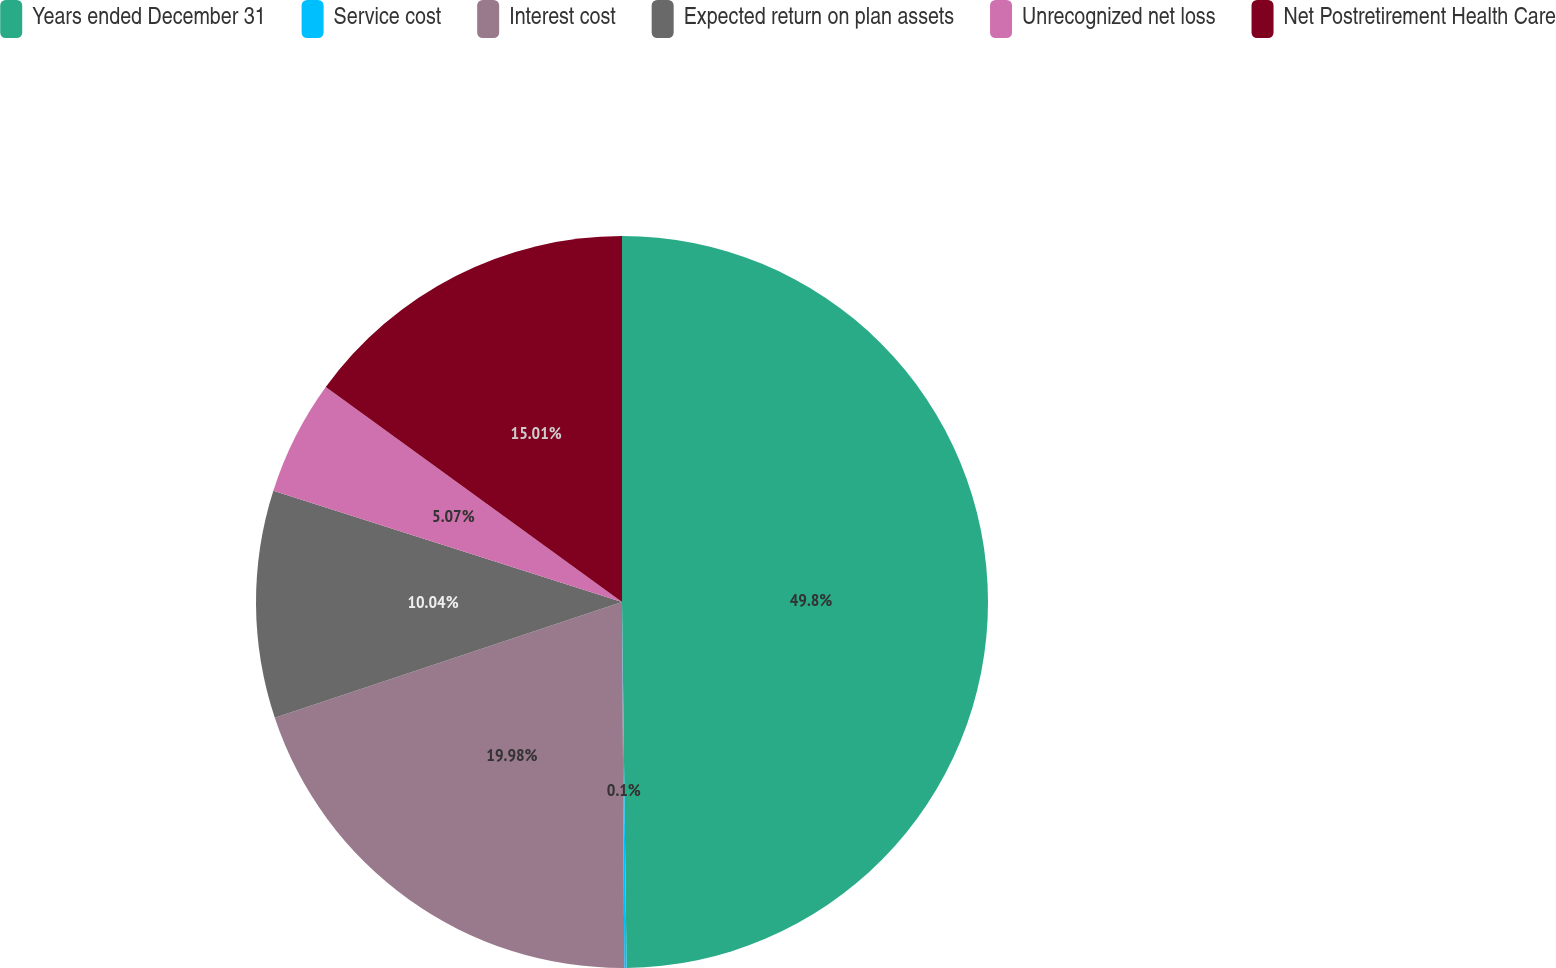<chart> <loc_0><loc_0><loc_500><loc_500><pie_chart><fcel>Years ended December 31<fcel>Service cost<fcel>Interest cost<fcel>Expected return on plan assets<fcel>Unrecognized net loss<fcel>Net Postretirement Health Care<nl><fcel>49.8%<fcel>0.1%<fcel>19.98%<fcel>10.04%<fcel>5.07%<fcel>15.01%<nl></chart> 